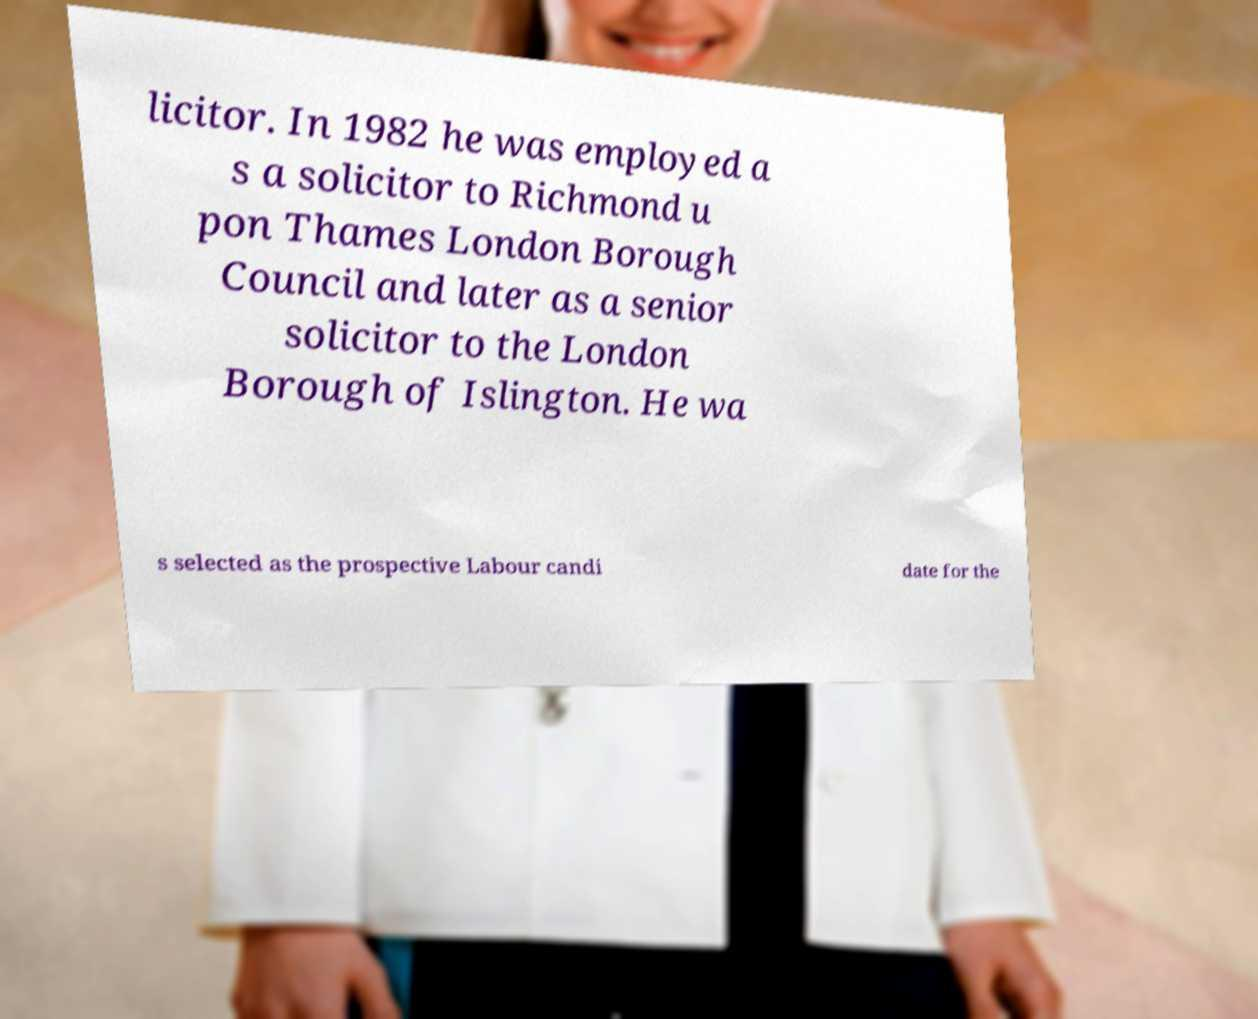Please identify and transcribe the text found in this image. licitor. In 1982 he was employed a s a solicitor to Richmond u pon Thames London Borough Council and later as a senior solicitor to the London Borough of Islington. He wa s selected as the prospective Labour candi date for the 